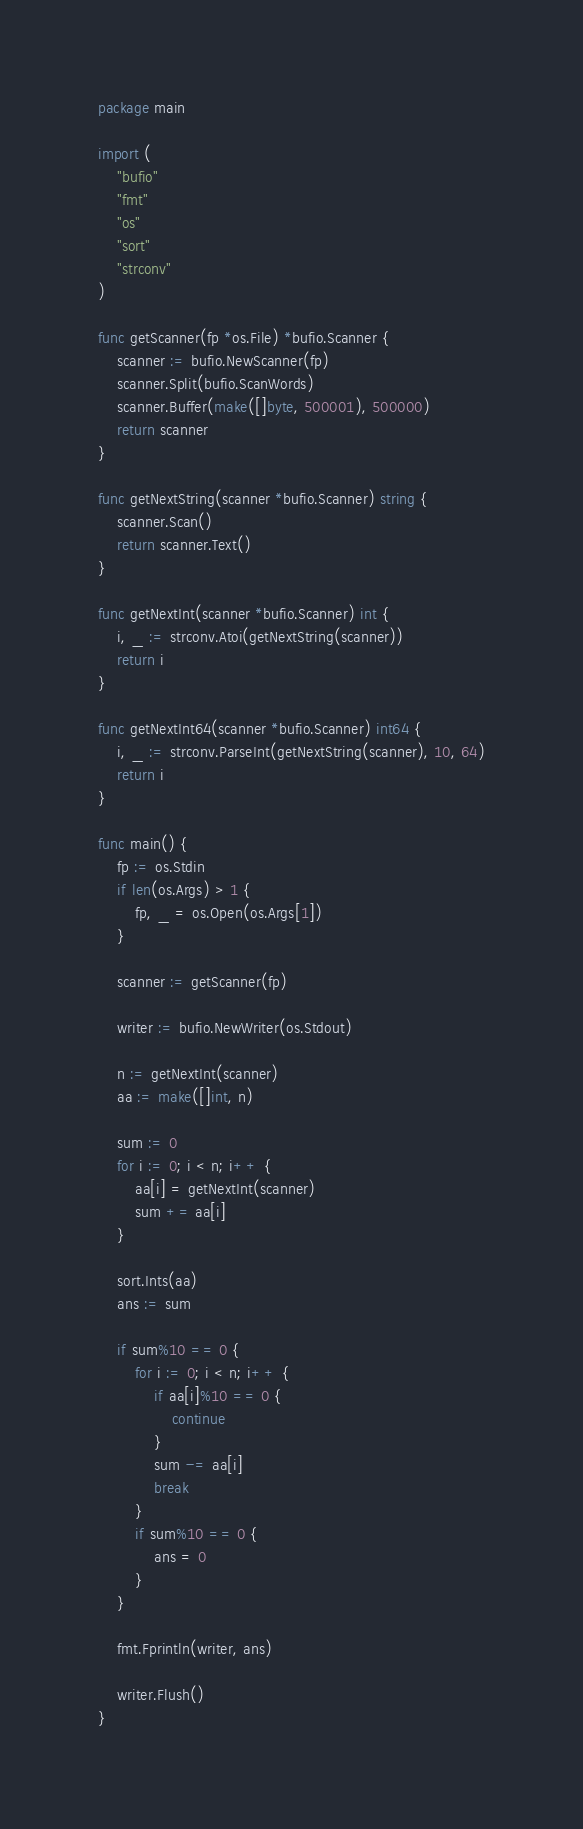Convert code to text. <code><loc_0><loc_0><loc_500><loc_500><_Go_>package main

import (
	"bufio"
	"fmt"
	"os"
	"sort"
	"strconv"
)

func getScanner(fp *os.File) *bufio.Scanner {
	scanner := bufio.NewScanner(fp)
	scanner.Split(bufio.ScanWords)
	scanner.Buffer(make([]byte, 500001), 500000)
	return scanner
}

func getNextString(scanner *bufio.Scanner) string {
	scanner.Scan()
	return scanner.Text()
}

func getNextInt(scanner *bufio.Scanner) int {
	i, _ := strconv.Atoi(getNextString(scanner))
	return i
}

func getNextInt64(scanner *bufio.Scanner) int64 {
	i, _ := strconv.ParseInt(getNextString(scanner), 10, 64)
	return i
}

func main() {
	fp := os.Stdin
	if len(os.Args) > 1 {
		fp, _ = os.Open(os.Args[1])
	}

	scanner := getScanner(fp)

	writer := bufio.NewWriter(os.Stdout)

	n := getNextInt(scanner)
	aa := make([]int, n)

	sum := 0
	for i := 0; i < n; i++ {
		aa[i] = getNextInt(scanner)
		sum += aa[i]
	}

	sort.Ints(aa)
	ans := sum

	if sum%10 == 0 {
		for i := 0; i < n; i++ {
			if aa[i]%10 == 0 {
				continue
			}
			sum -= aa[i]
			break
		}
		if sum%10 == 0 {
			ans = 0
		}
	}

	fmt.Fprintln(writer, ans)

	writer.Flush()
}
</code> 